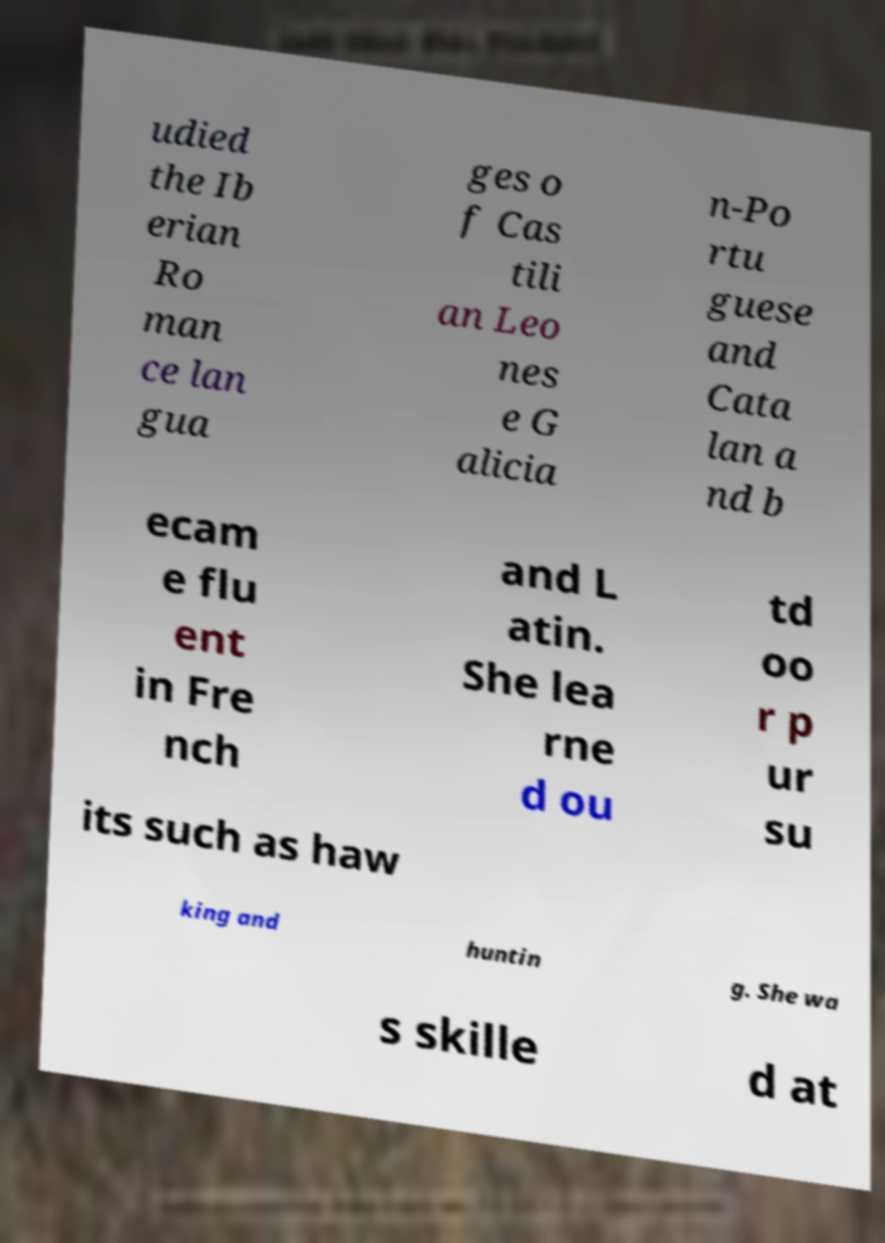Please identify and transcribe the text found in this image. udied the Ib erian Ro man ce lan gua ges o f Cas tili an Leo nes e G alicia n-Po rtu guese and Cata lan a nd b ecam e flu ent in Fre nch and L atin. She lea rne d ou td oo r p ur su its such as haw king and huntin g. She wa s skille d at 